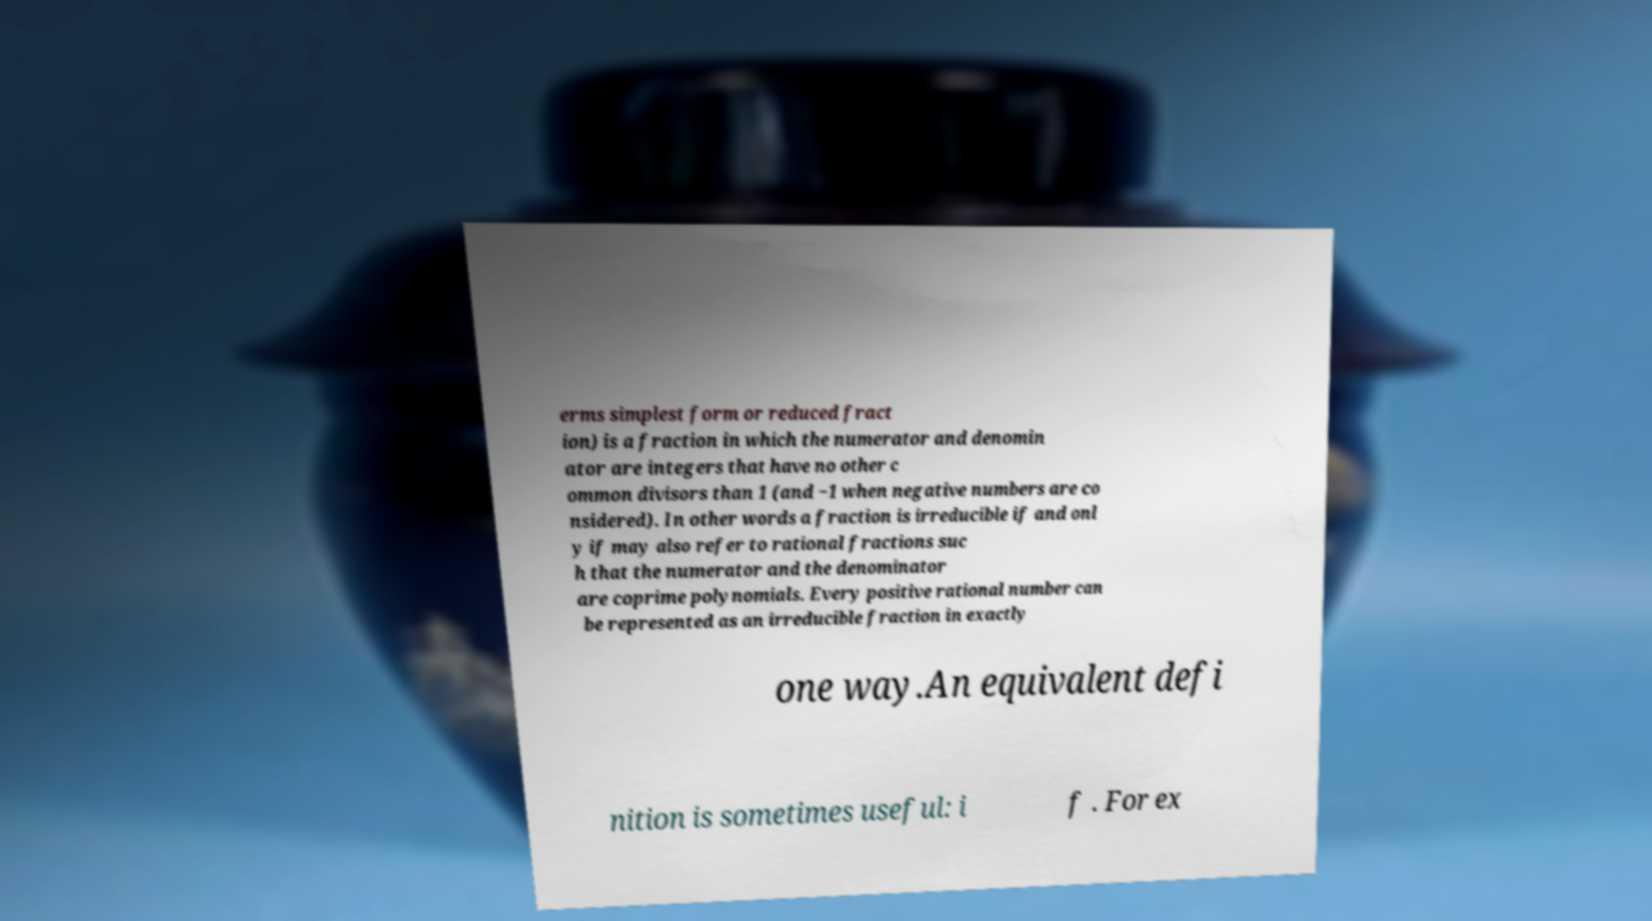Please identify and transcribe the text found in this image. erms simplest form or reduced fract ion) is a fraction in which the numerator and denomin ator are integers that have no other c ommon divisors than 1 (and −1 when negative numbers are co nsidered). In other words a fraction is irreducible if and onl y if may also refer to rational fractions suc h that the numerator and the denominator are coprime polynomials. Every positive rational number can be represented as an irreducible fraction in exactly one way.An equivalent defi nition is sometimes useful: i f . For ex 